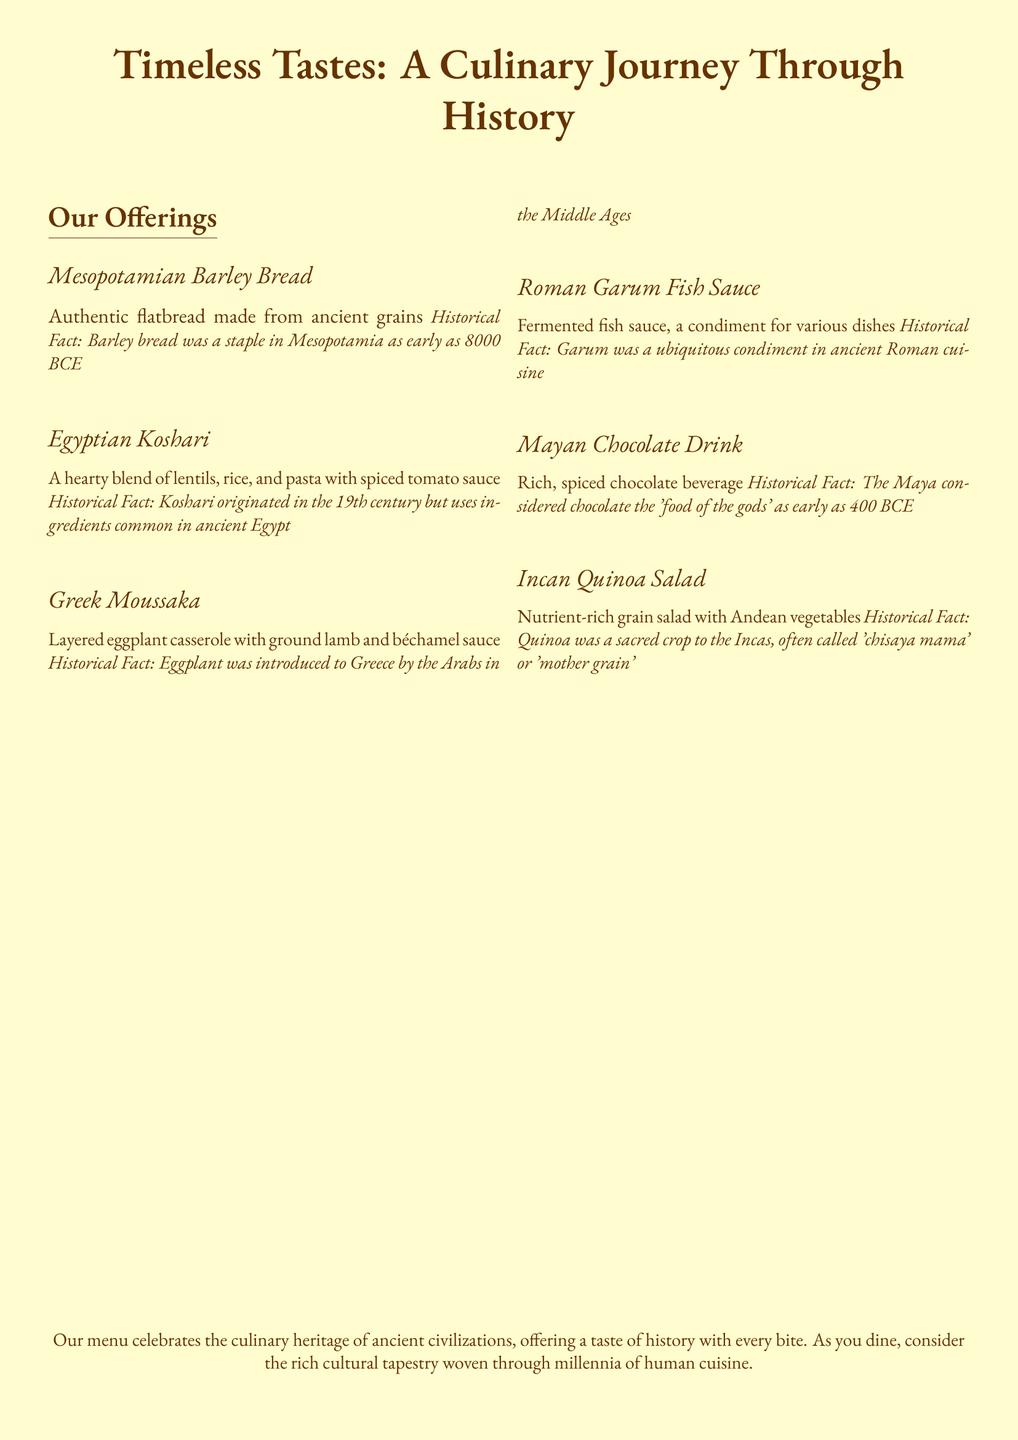What is the first dish listed on the menu? The first dish listed in the offerings section is Mesopotamian Barley Bread.
Answer: Mesopotamian Barley Bread What ancient grain is used in the Mesopotamian Barley Bread? The bread is made from barley, which is an ancient grain.
Answer: Barley What dish is associated with lentils, rice, and pasta? The dish that includes lentils, rice, and pasta is Egyptian Koshari.
Answer: Egyptian Koshari In what century did Koshari originate? Koshari originated in the 19th century according to the historical note.
Answer: 19th century Which vegetable was introduced to Greece by the Arabs? The vegetable introduced to Greece by the Arabs is eggplant.
Answer: Eggplant What condiment was ubiquitous in ancient Roman cuisine? The condiment that was common in ancient Rome is Garum fish sauce.
Answer: Garum What did the Maya consider chocolate? The Maya referred to chocolate as the 'food of the gods.'
Answer: 'food of the gods' What is quinoa often called by the Incas? Quinoa is referred to as 'chisaya mama' by the Incas.
Answer: 'chisaya mama' How many dishes are featured in the menu? There are six dishes mentioned in the offerings section.
Answer: Six dishes 